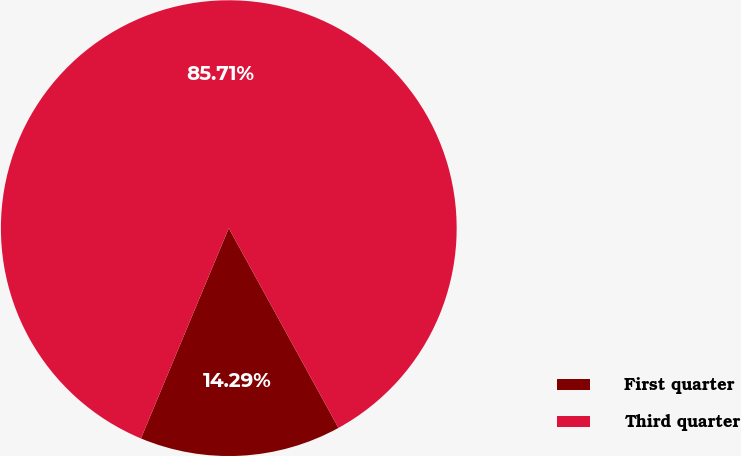<chart> <loc_0><loc_0><loc_500><loc_500><pie_chart><fcel>First quarter<fcel>Third quarter<nl><fcel>14.29%<fcel>85.71%<nl></chart> 